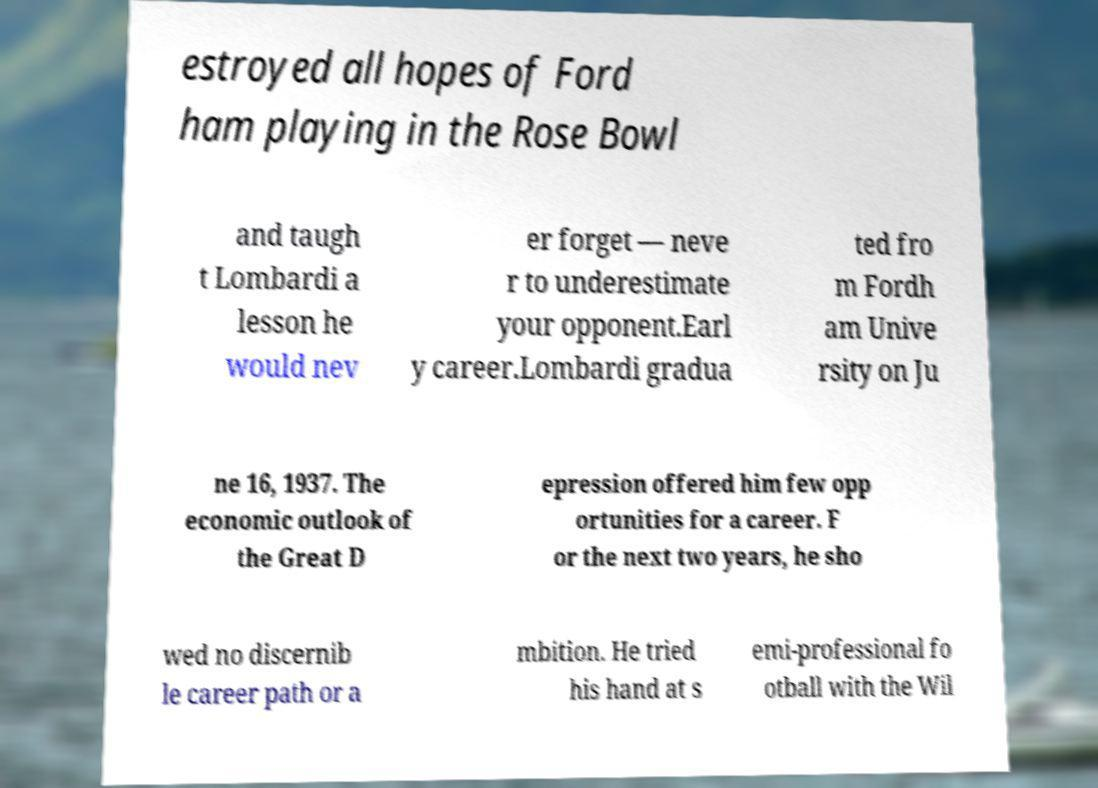Please identify and transcribe the text found in this image. estroyed all hopes of Ford ham playing in the Rose Bowl and taugh t Lombardi a lesson he would nev er forget — neve r to underestimate your opponent.Earl y career.Lombardi gradua ted fro m Fordh am Unive rsity on Ju ne 16, 1937. The economic outlook of the Great D epression offered him few opp ortunities for a career. F or the next two years, he sho wed no discernib le career path or a mbition. He tried his hand at s emi-professional fo otball with the Wil 